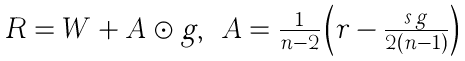<formula> <loc_0><loc_0><loc_500><loc_500>\begin{array} { c c c } R = W + A \odot g , & A = \frac { 1 } { n - 2 } \left ( r - \frac { s \, g } { 2 ( n - 1 ) } \right ) & \end{array}</formula> 